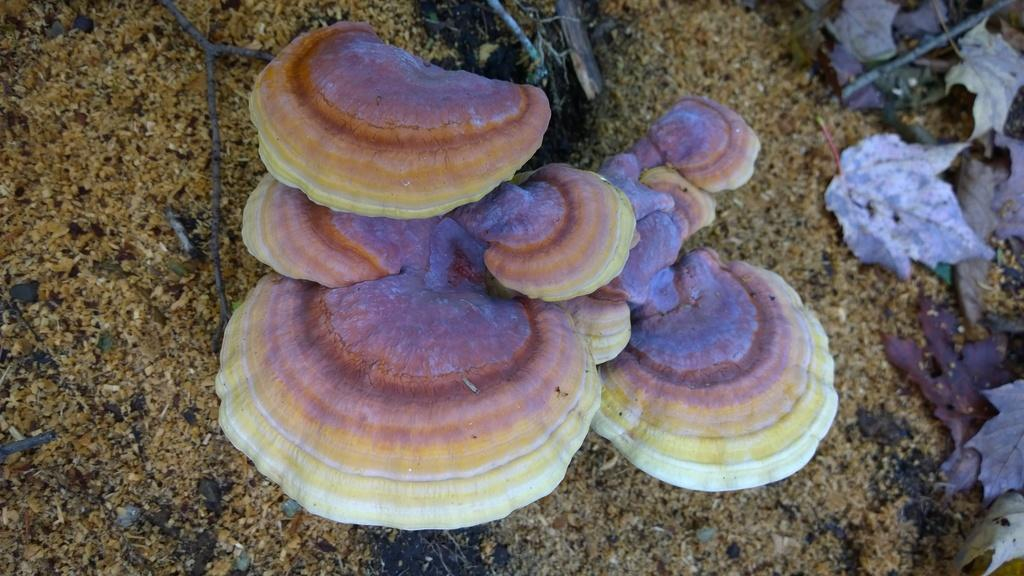What type of plant can be seen in the image? There is a mushroom in the image. What type of natural material is present in the image? There are dry leaves in the image. What object made of wood can be seen in the image? There is a wooden stick in the image. What type of terrain is visible in the image? There is sand in the image. What type of vegetable is being used to make a smoothie in the image? There is no vegetable or smoothie present in the image; it features a mushroom, dry leaves, a wooden stick, and sand. 